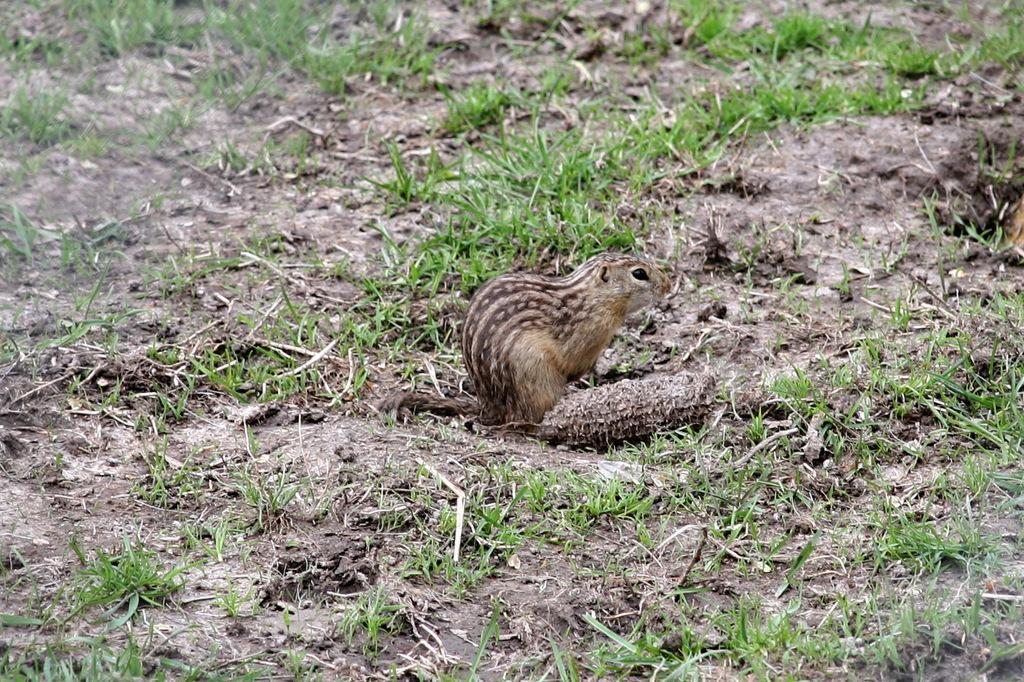How would you summarize this image in a sentence or two? In the image there is a squirrel standing on the grassland. 